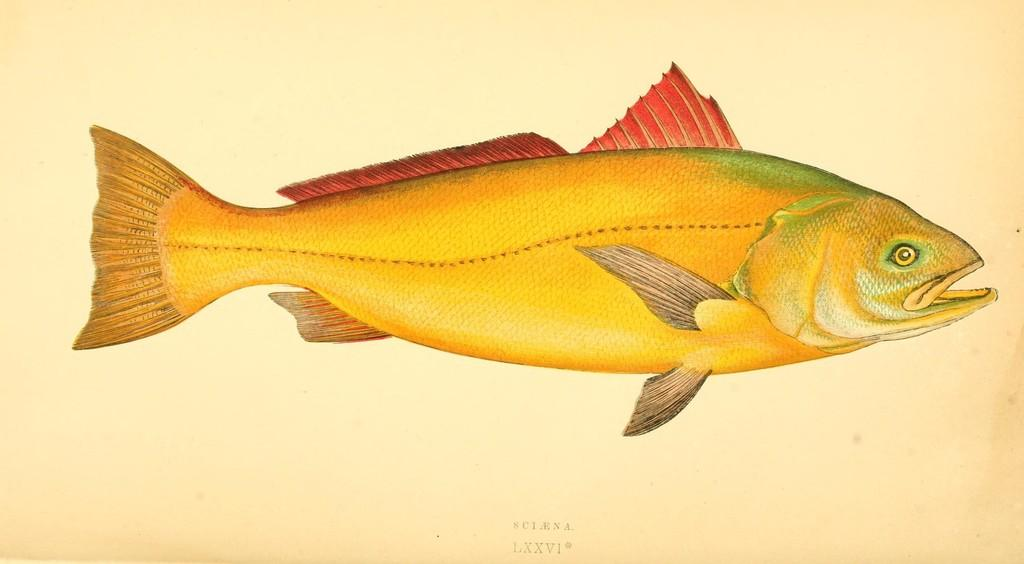What is the main subject of the paper in the image? The paper contains a diagram of a fish. Are there any symbols or numbers on the paper? Yes, Roman numerals are present on the paper. Are there any letters on the paper? Yes, letters are present on the paper. How many deer can be seen grazing in the image? There are no deer present in the image; it features a paper with a diagram of a fish, Roman numerals, and letters. What type of sugar is used to sweeten the letters on the paper? There is no sugar present in the image, as it features a paper with a diagram of a fish, Roman numerals, and letters. 